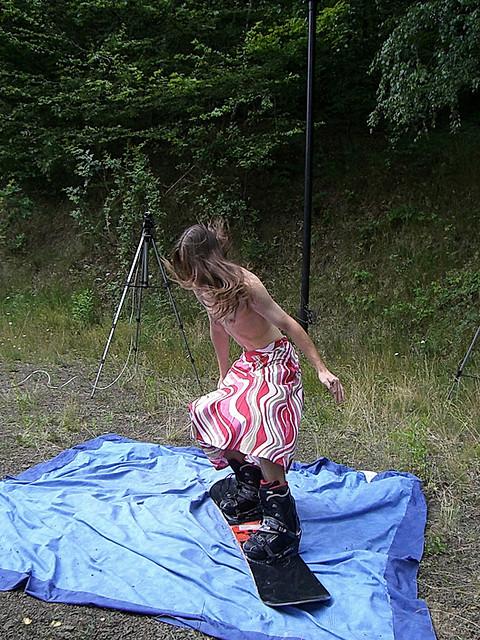Where is the tripod?
Give a very brief answer. Behind. Is there a tripod?
Give a very brief answer. Yes. What is the man doing?
Write a very short answer. Standing on snowboard. Does the person have short hair?
Answer briefly. No. 